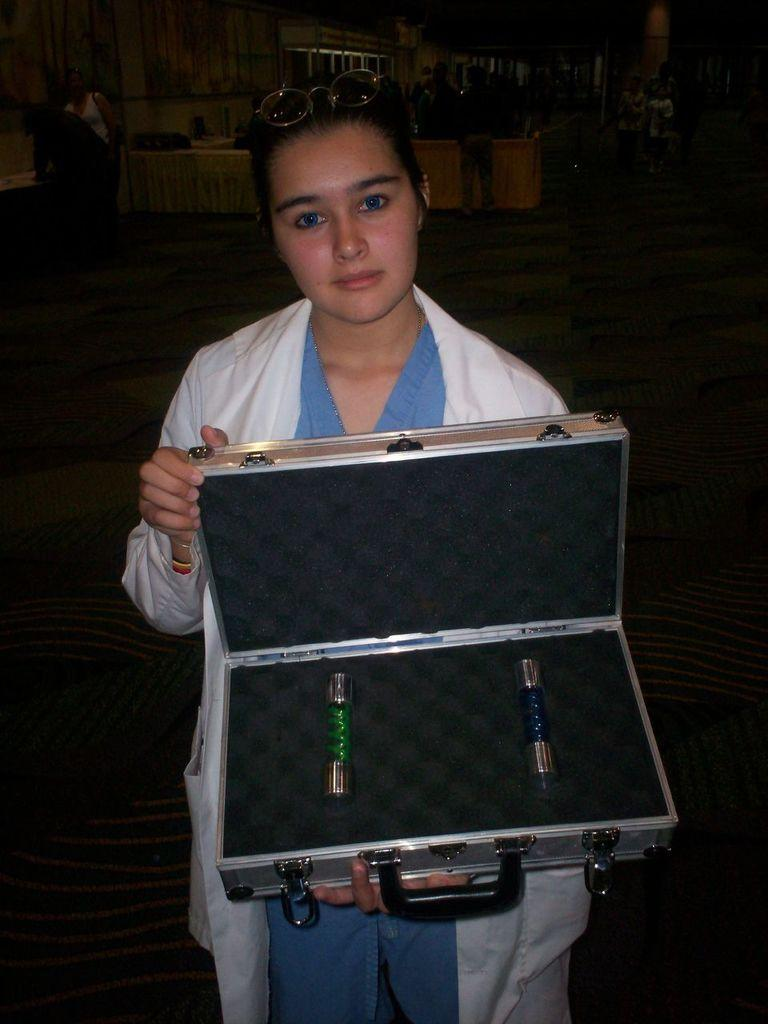What is the woman in the image wearing? The woman is wearing a white jacket. What is the woman holding in the image? The woman is holding a box with two bottles. Can you describe the other people in the image? There are other persons standing far away in the image. What type of furniture can be seen in the image? There are tables present in the image. What type of sheet is being used as an instrument by the woman in the image? There is no sheet present in the image, nor is it being used as an instrument by the woman. 